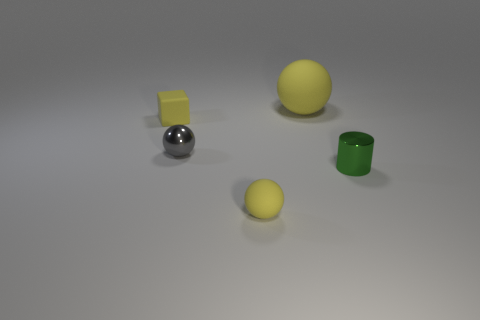Add 3 large yellow spheres. How many objects exist? 8 Subtract all spheres. How many objects are left? 2 Subtract all tiny yellow balls. Subtract all yellow blocks. How many objects are left? 3 Add 5 large yellow matte objects. How many large yellow matte objects are left? 6 Add 3 small metal objects. How many small metal objects exist? 5 Subtract 0 blue balls. How many objects are left? 5 